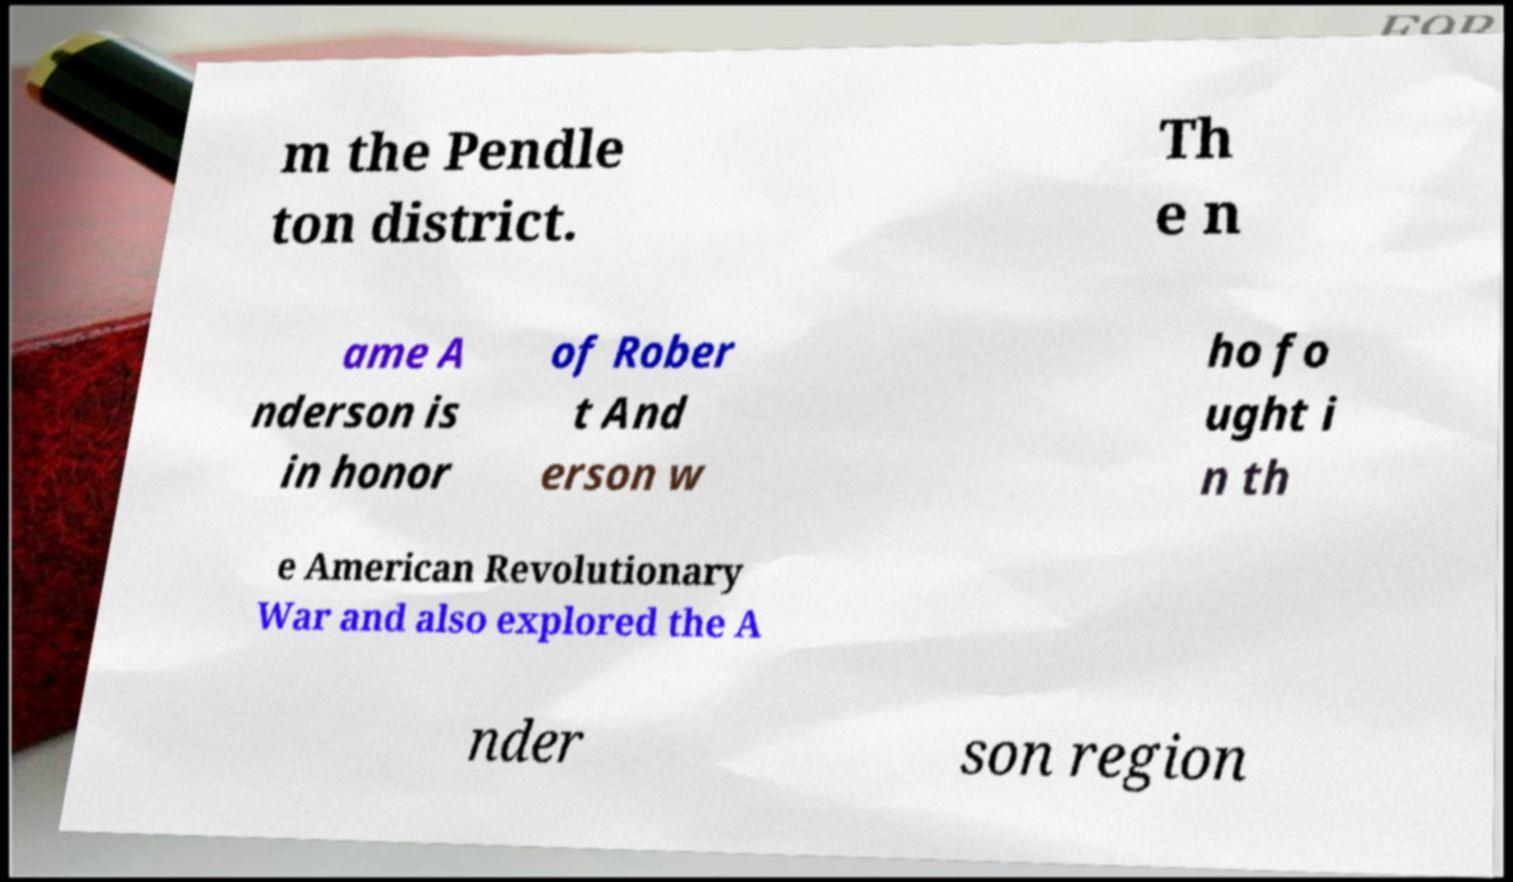What messages or text are displayed in this image? I need them in a readable, typed format. m the Pendle ton district. Th e n ame A nderson is in honor of Rober t And erson w ho fo ught i n th e American Revolutionary War and also explored the A nder son region 